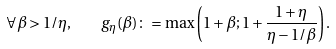Convert formula to latex. <formula><loc_0><loc_0><loc_500><loc_500>\forall \beta > 1 / \eta , \quad g _ { \eta } ( \beta ) \colon = \max \left ( 1 + \beta ; 1 + \frac { 1 + \eta } { \eta - 1 / \beta } \right ) .</formula> 